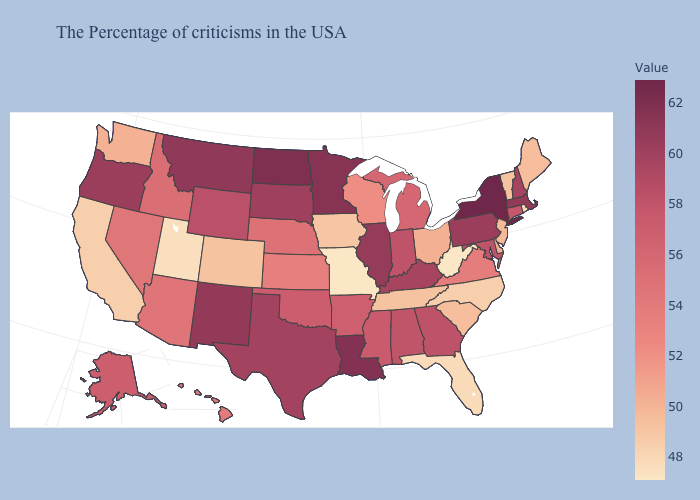Does Oklahoma have the highest value in the USA?
Quick response, please. No. Does South Dakota have the lowest value in the MidWest?
Give a very brief answer. No. Does Maine have the highest value in the USA?
Short answer required. No. Which states hav the highest value in the South?
Be succinct. Louisiana. Is the legend a continuous bar?
Give a very brief answer. Yes. 